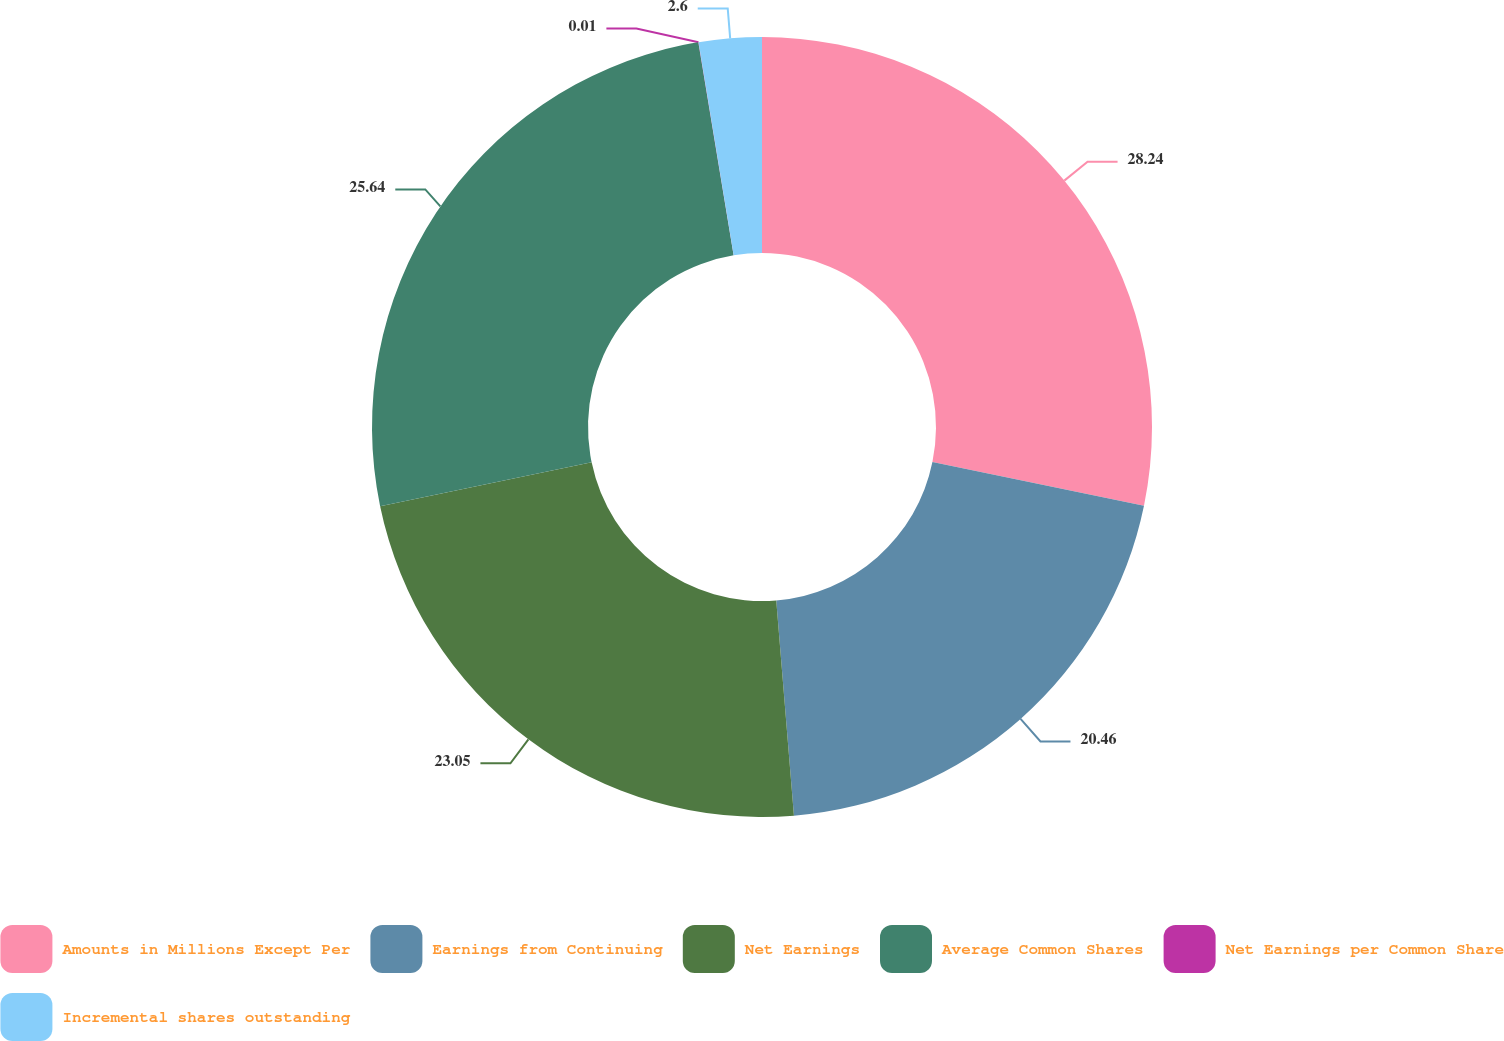<chart> <loc_0><loc_0><loc_500><loc_500><pie_chart><fcel>Amounts in Millions Except Per<fcel>Earnings from Continuing<fcel>Net Earnings<fcel>Average Common Shares<fcel>Net Earnings per Common Share<fcel>Incremental shares outstanding<nl><fcel>28.23%<fcel>20.46%<fcel>23.05%<fcel>25.64%<fcel>0.01%<fcel>2.6%<nl></chart> 